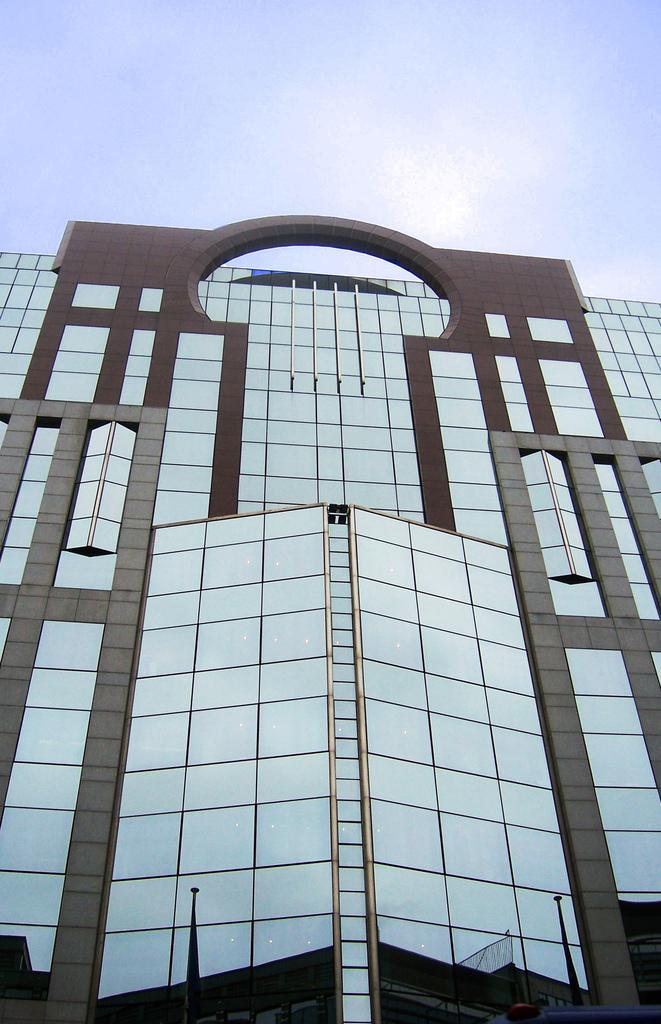What type of structure is present in the image? There is a building in the image. What can be seen in the background of the image? The sky is visible in the background of the image. What type of meal is being prepared in the building in the image? There is no indication of a meal being prepared in the building in the image. What health benefits can be gained from the building in the image? The image does not provide any information about health benefits associated with the building. 